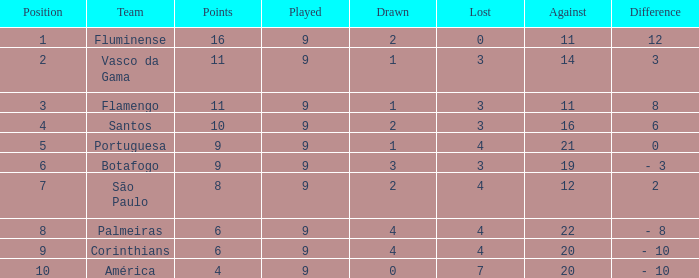Which Against is the highest one that has a Difference of 12? 11.0. 